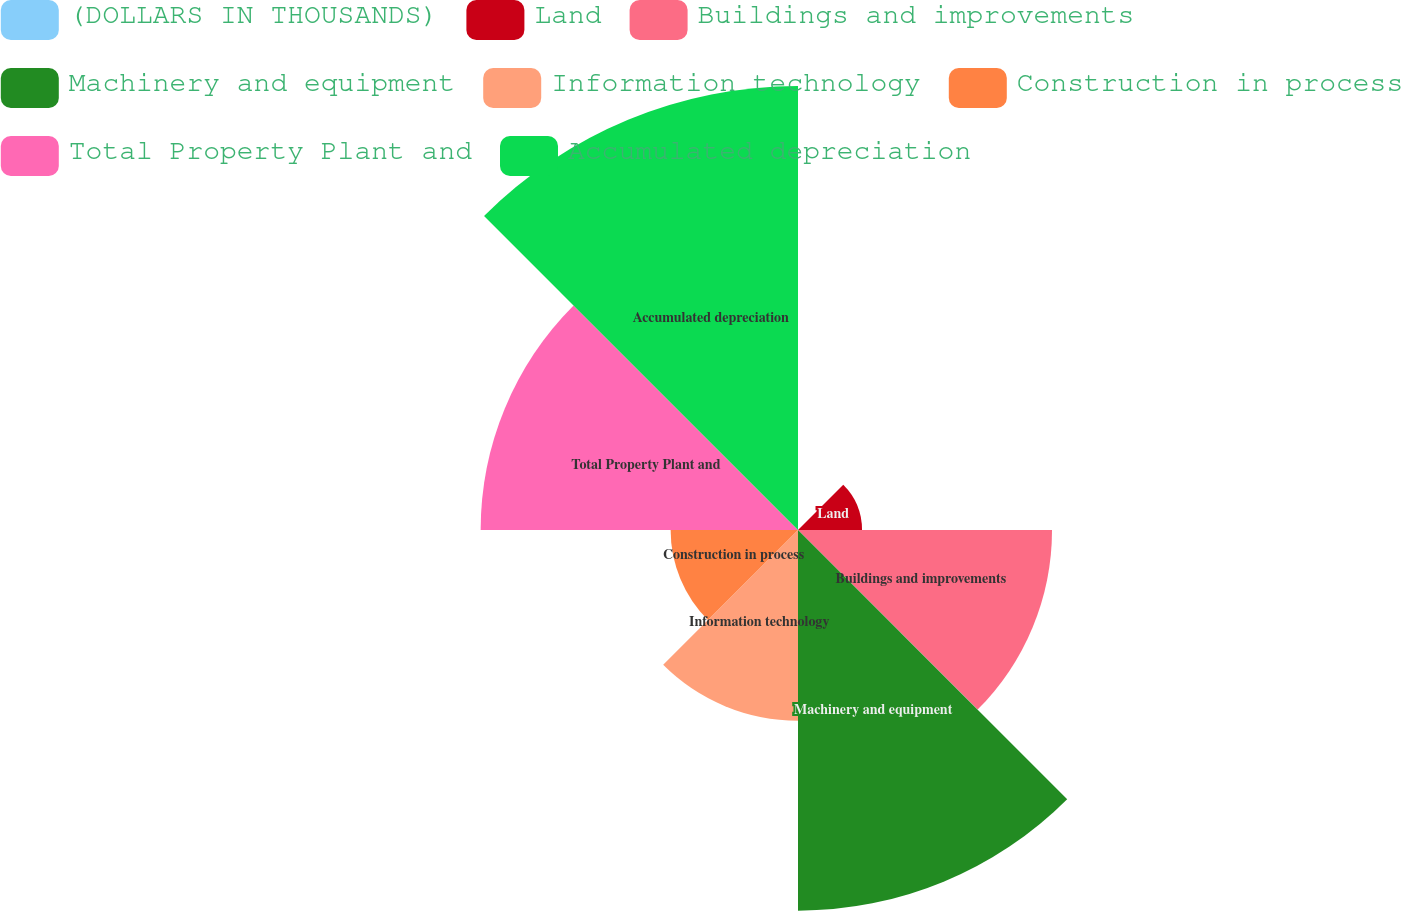<chart> <loc_0><loc_0><loc_500><loc_500><pie_chart><fcel>(DOLLARS IN THOUSANDS)<fcel>Land<fcel>Buildings and improvements<fcel>Machinery and equipment<fcel>Information technology<fcel>Construction in process<fcel>Total Property Plant and<fcel>Accumulated depreciation<nl><fcel>0.04%<fcel>3.6%<fcel>14.28%<fcel>21.4%<fcel>10.72%<fcel>7.16%<fcel>17.84%<fcel>24.96%<nl></chart> 